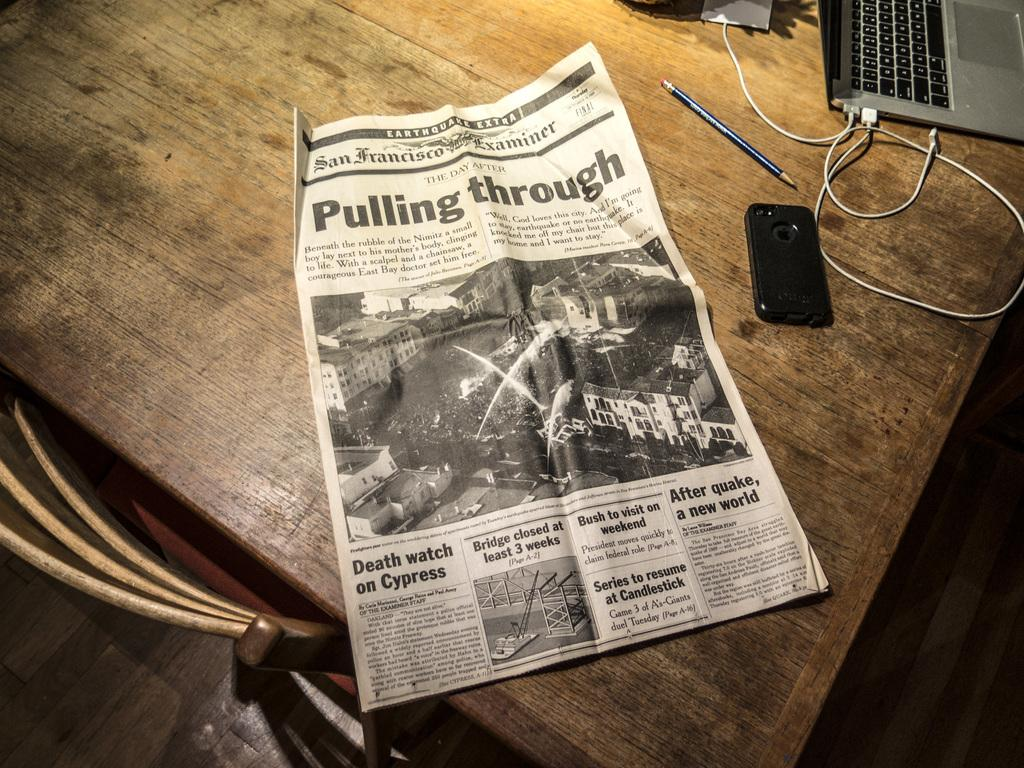<image>
Write a terse but informative summary of the picture. The San Francisco Examiner has a headline reading Pulling Through. 